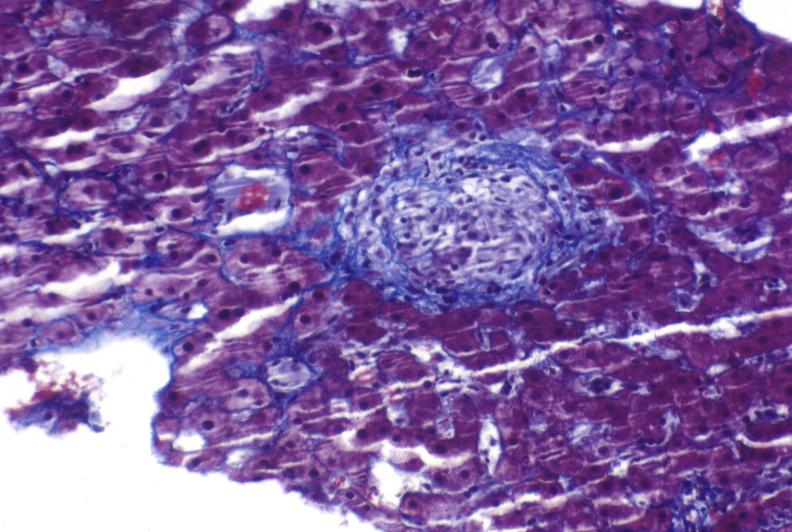s liver present?
Answer the question using a single word or phrase. Yes 